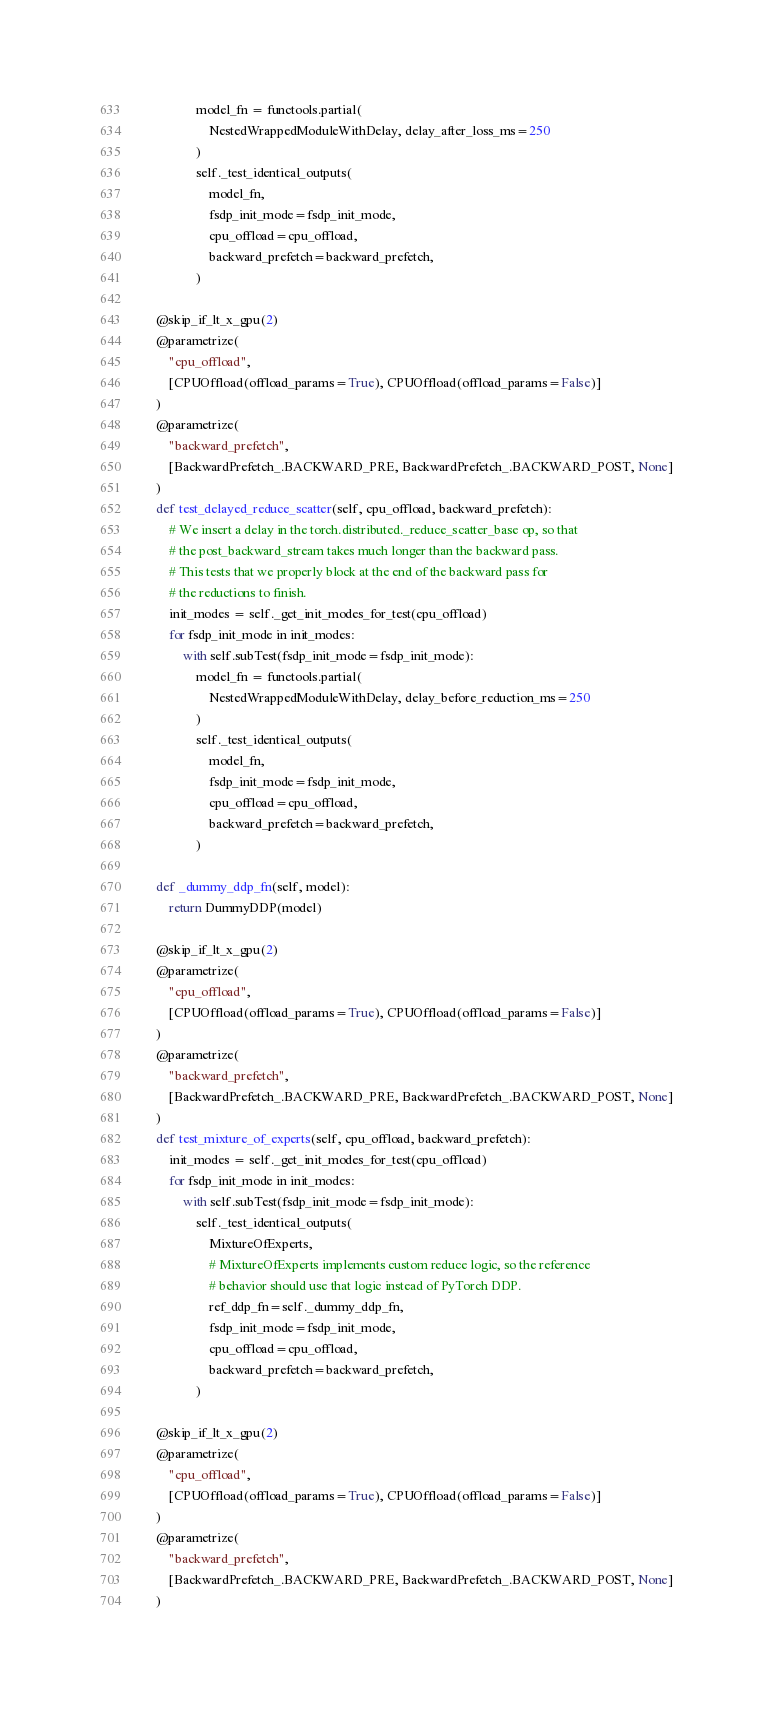Convert code to text. <code><loc_0><loc_0><loc_500><loc_500><_Python_>                model_fn = functools.partial(
                    NestedWrappedModuleWithDelay, delay_after_loss_ms=250
                )
                self._test_identical_outputs(
                    model_fn,
                    fsdp_init_mode=fsdp_init_mode,
                    cpu_offload=cpu_offload,
                    backward_prefetch=backward_prefetch,
                )

    @skip_if_lt_x_gpu(2)
    @parametrize(
        "cpu_offload",
        [CPUOffload(offload_params=True), CPUOffload(offload_params=False)]
    )
    @parametrize(
        "backward_prefetch",
        [BackwardPrefetch_.BACKWARD_PRE, BackwardPrefetch_.BACKWARD_POST, None]
    )
    def test_delayed_reduce_scatter(self, cpu_offload, backward_prefetch):
        # We insert a delay in the torch.distributed._reduce_scatter_base op, so that
        # the post_backward_stream takes much longer than the backward pass.
        # This tests that we properly block at the end of the backward pass for
        # the reductions to finish.
        init_modes = self._get_init_modes_for_test(cpu_offload)
        for fsdp_init_mode in init_modes:
            with self.subTest(fsdp_init_mode=fsdp_init_mode):
                model_fn = functools.partial(
                    NestedWrappedModuleWithDelay, delay_before_reduction_ms=250
                )
                self._test_identical_outputs(
                    model_fn,
                    fsdp_init_mode=fsdp_init_mode,
                    cpu_offload=cpu_offload,
                    backward_prefetch=backward_prefetch,
                )

    def _dummy_ddp_fn(self, model):
        return DummyDDP(model)

    @skip_if_lt_x_gpu(2)
    @parametrize(
        "cpu_offload",
        [CPUOffload(offload_params=True), CPUOffload(offload_params=False)]
    )
    @parametrize(
        "backward_prefetch",
        [BackwardPrefetch_.BACKWARD_PRE, BackwardPrefetch_.BACKWARD_POST, None]
    )
    def test_mixture_of_experts(self, cpu_offload, backward_prefetch):
        init_modes = self._get_init_modes_for_test(cpu_offload)
        for fsdp_init_mode in init_modes:
            with self.subTest(fsdp_init_mode=fsdp_init_mode):
                self._test_identical_outputs(
                    MixtureOfExperts,
                    # MixtureOfExperts implements custom reduce logic, so the reference
                    # behavior should use that logic instead of PyTorch DDP.
                    ref_ddp_fn=self._dummy_ddp_fn,
                    fsdp_init_mode=fsdp_init_mode,
                    cpu_offload=cpu_offload,
                    backward_prefetch=backward_prefetch,
                )

    @skip_if_lt_x_gpu(2)
    @parametrize(
        "cpu_offload",
        [CPUOffload(offload_params=True), CPUOffload(offload_params=False)]
    )
    @parametrize(
        "backward_prefetch",
        [BackwardPrefetch_.BACKWARD_PRE, BackwardPrefetch_.BACKWARD_POST, None]
    )</code> 